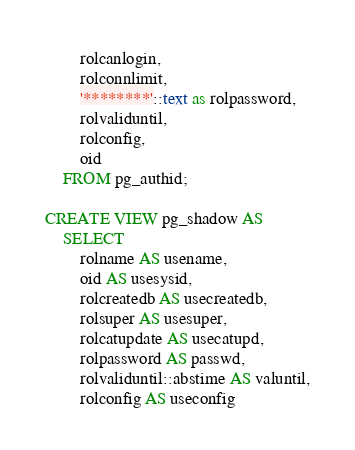Convert code to text. <code><loc_0><loc_0><loc_500><loc_500><_SQL_>        rolcanlogin,
        rolconnlimit,
        '********'::text as rolpassword,
        rolvaliduntil,
        rolconfig,
        oid
    FROM pg_authid;

CREATE VIEW pg_shadow AS
    SELECT
        rolname AS usename,
        oid AS usesysid,
        rolcreatedb AS usecreatedb,
        rolsuper AS usesuper,
        rolcatupdate AS usecatupd,
        rolpassword AS passwd,
        rolvaliduntil::abstime AS valuntil,
        rolconfig AS useconfig</code> 